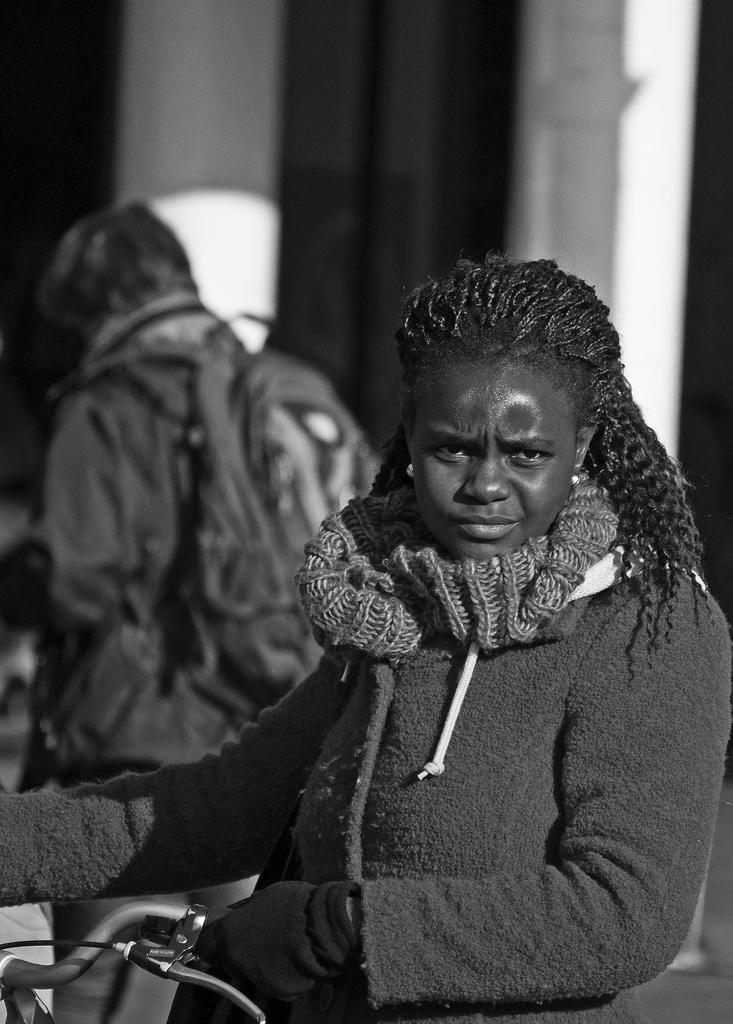What is the color scheme of the image? The image is black and white. Who is present in the image? There is a woman in the image. What is the woman doing in the image? The woman is standing and holding a bicycle. Can you describe the background of the image? There is a person in the background of the image. How many children are reading a book in the image? There are no children or books present in the image. What type of lawyer is advising the woman in the image? There is no lawyer present in the image. 